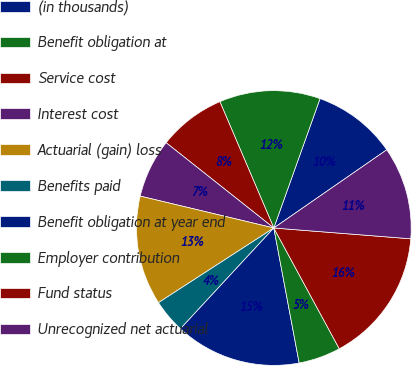Convert chart to OTSL. <chart><loc_0><loc_0><loc_500><loc_500><pie_chart><fcel>(in thousands)<fcel>Benefit obligation at<fcel>Service cost<fcel>Interest cost<fcel>Actuarial (gain) loss<fcel>Benefits paid<fcel>Benefit obligation at year end<fcel>Employer contribution<fcel>Fund status<fcel>Unrecognized net actuarial<nl><fcel>9.9%<fcel>11.88%<fcel>7.92%<fcel>6.93%<fcel>12.87%<fcel>3.96%<fcel>14.85%<fcel>4.95%<fcel>15.84%<fcel>10.89%<nl></chart> 